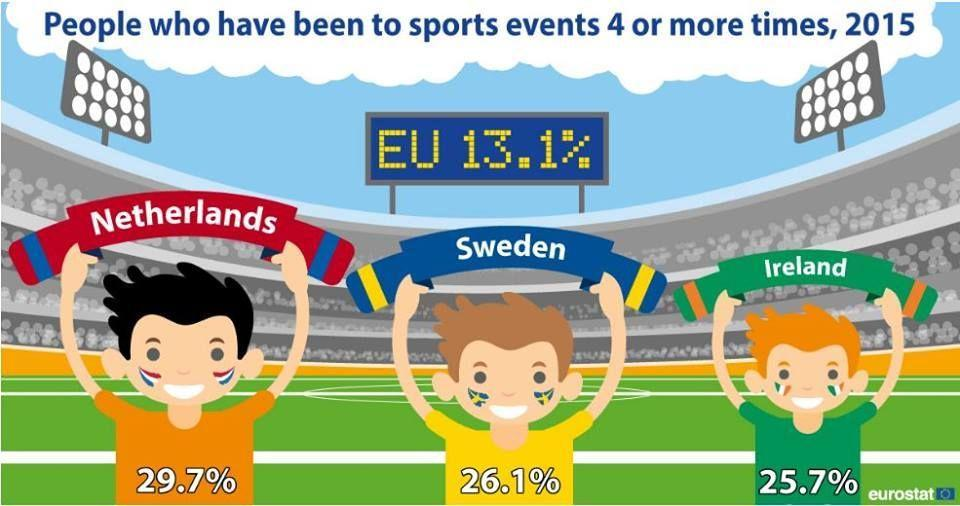What colour is the boy's shirt holding Sweden- yellow, orange or green?
Answer the question with a short phrase. Yellow People of which country have been to sports events the most in 2015? Netherlands 